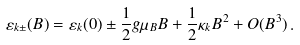<formula> <loc_0><loc_0><loc_500><loc_500>\varepsilon _ { k \pm } ( B ) = \varepsilon _ { k } ( 0 ) \pm \frac { 1 } { 2 } g \mu _ { B } B + \frac { 1 } { 2 } \kappa _ { k } B ^ { 2 } + O ( B ^ { 3 } ) \, .</formula> 